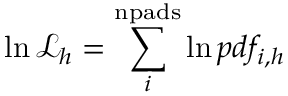<formula> <loc_0><loc_0><loc_500><loc_500>\ln \mathcal { L } _ { h } = \sum _ { i } ^ { n p a d s } \ln p d f _ { i , h }</formula> 